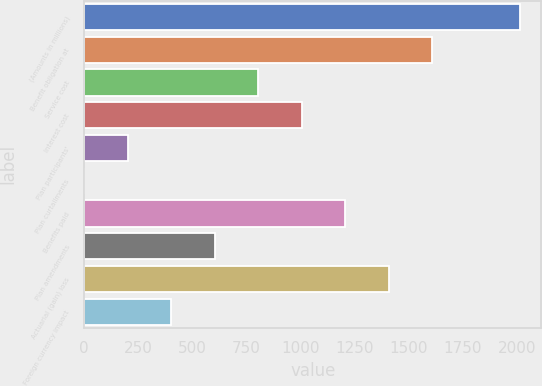<chart> <loc_0><loc_0><loc_500><loc_500><bar_chart><fcel>(Amounts in millions)<fcel>Benefit obligation at<fcel>Service cost<fcel>Interest cost<fcel>Plan participants'<fcel>Plan curtailments<fcel>Benefits paid<fcel>Plan amendments<fcel>Actuarial (gain) loss<fcel>Foreign currency impact<nl><fcel>2012<fcel>1609.62<fcel>804.86<fcel>1006.05<fcel>201.29<fcel>0.1<fcel>1207.24<fcel>603.67<fcel>1408.43<fcel>402.48<nl></chart> 